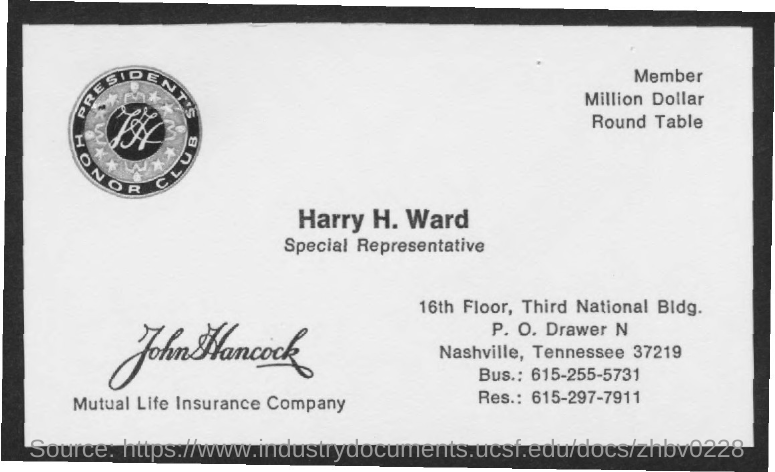Outline some significant characteristics in this image. The res. no. mentioned is 615-297-7911. I am seeking information on a mutual life insurance company that was mentioned in a conversation. The bus number mentioned is 615-255-5731. 